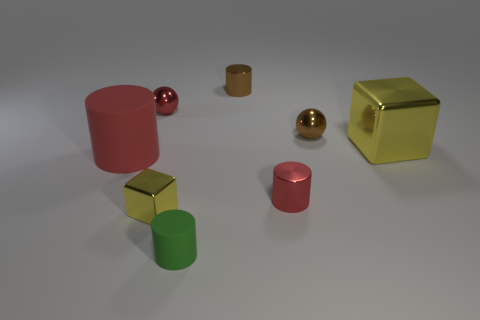Subtract 1 cylinders. How many cylinders are left? 3 Subtract all blue cylinders. Subtract all green blocks. How many cylinders are left? 4 Add 1 large red matte cylinders. How many objects exist? 9 Subtract all cubes. How many objects are left? 6 Subtract all brown shiny cylinders. Subtract all green objects. How many objects are left? 6 Add 4 green things. How many green things are left? 5 Add 5 red metallic cylinders. How many red metallic cylinders exist? 6 Subtract 1 green cylinders. How many objects are left? 7 